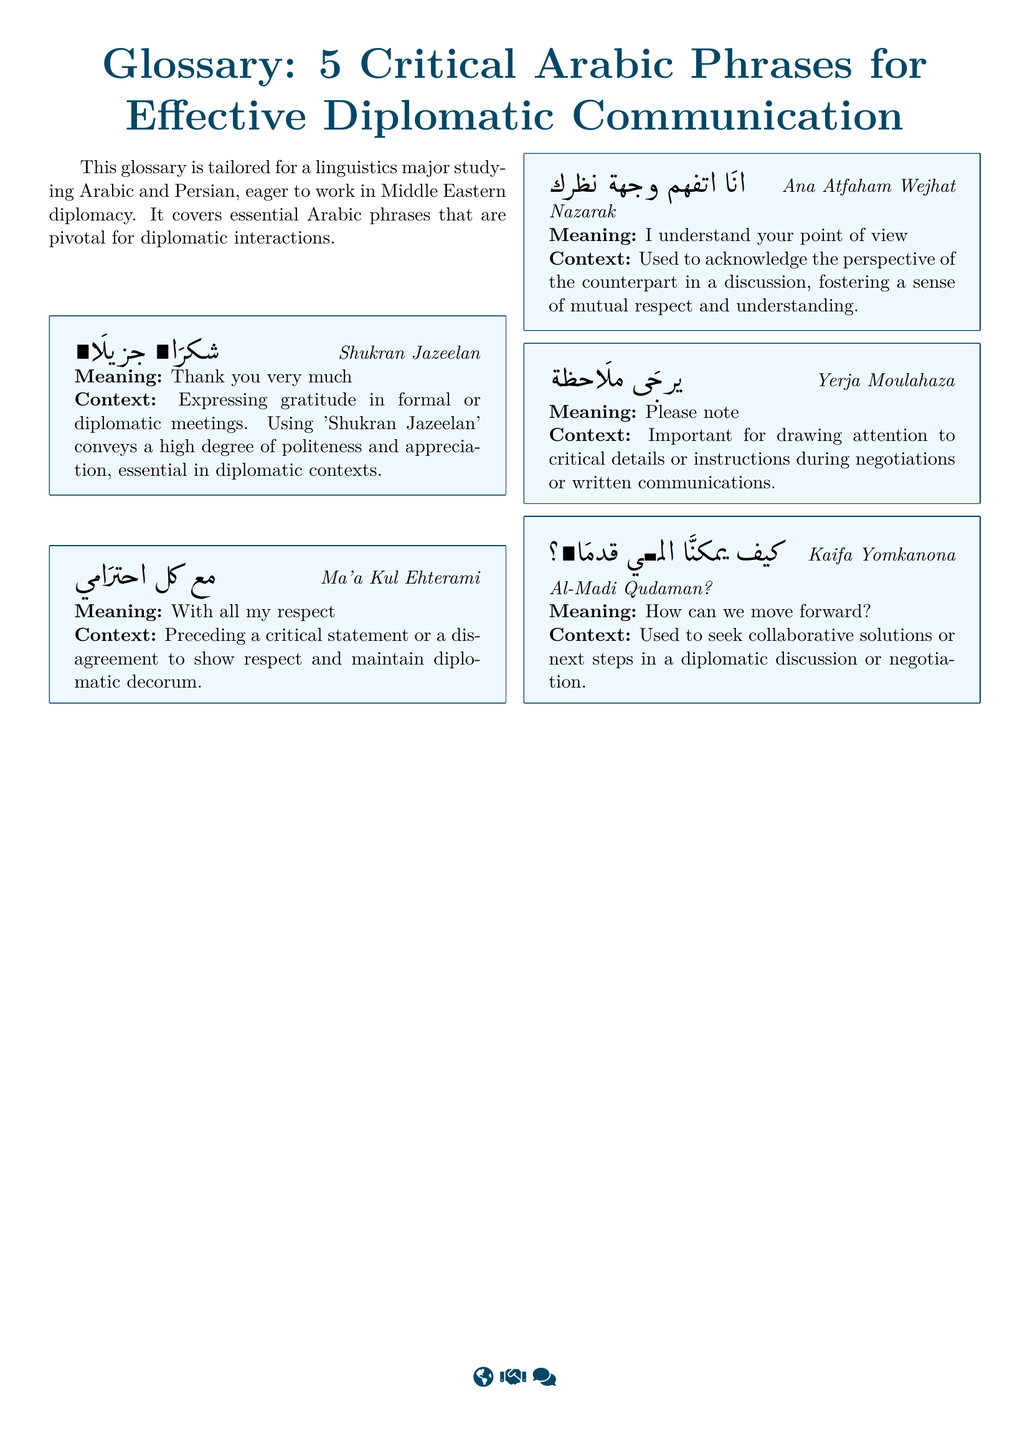What is the first critical Arabic phrase listed? The first critical phrase in the glossary is listed as "Shukran Jazeelan".
Answer: Shukran Jazeelan What does "Ma'a Kul Ehterami" mean? The glossary provides the meaning of "Ma'a Kul Ehterami" as "With all my respect".
Answer: With all my respect How many phrases are included in the glossary? The document explicitly states that there are 5 critical Arabic phrases included in the glossary.
Answer: 5 What is the purpose of using "Yerja Moulahaza"? According to the glossary, "Yerja Moulahaza" is used to draw attention to critical details or instructions during negotiations.
Answer: Please note Which phrase is used to express understanding of another's perspective? The glossary indicates that "Ana Atfaham Wejhat Nazarak" is used for this purpose.
Answer: Ana Atfaham Wejhat Nazarak What component of diplomatic communication does the phrase "Kaifa Yomkanona Al-Madi Qudaman?" relate to? The glossary states that this phrase is related to seeking collaborative solutions or next steps in a diplomatic discussion.
Answer: How can we move forward? 